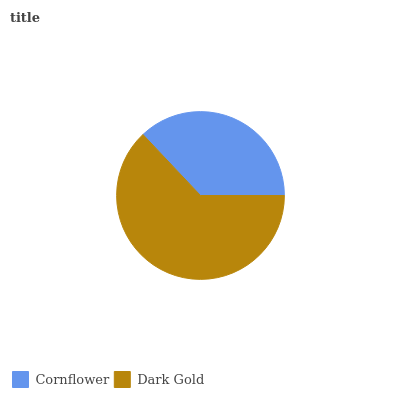Is Cornflower the minimum?
Answer yes or no. Yes. Is Dark Gold the maximum?
Answer yes or no. Yes. Is Dark Gold the minimum?
Answer yes or no. No. Is Dark Gold greater than Cornflower?
Answer yes or no. Yes. Is Cornflower less than Dark Gold?
Answer yes or no. Yes. Is Cornflower greater than Dark Gold?
Answer yes or no. No. Is Dark Gold less than Cornflower?
Answer yes or no. No. Is Dark Gold the high median?
Answer yes or no. Yes. Is Cornflower the low median?
Answer yes or no. Yes. Is Cornflower the high median?
Answer yes or no. No. Is Dark Gold the low median?
Answer yes or no. No. 